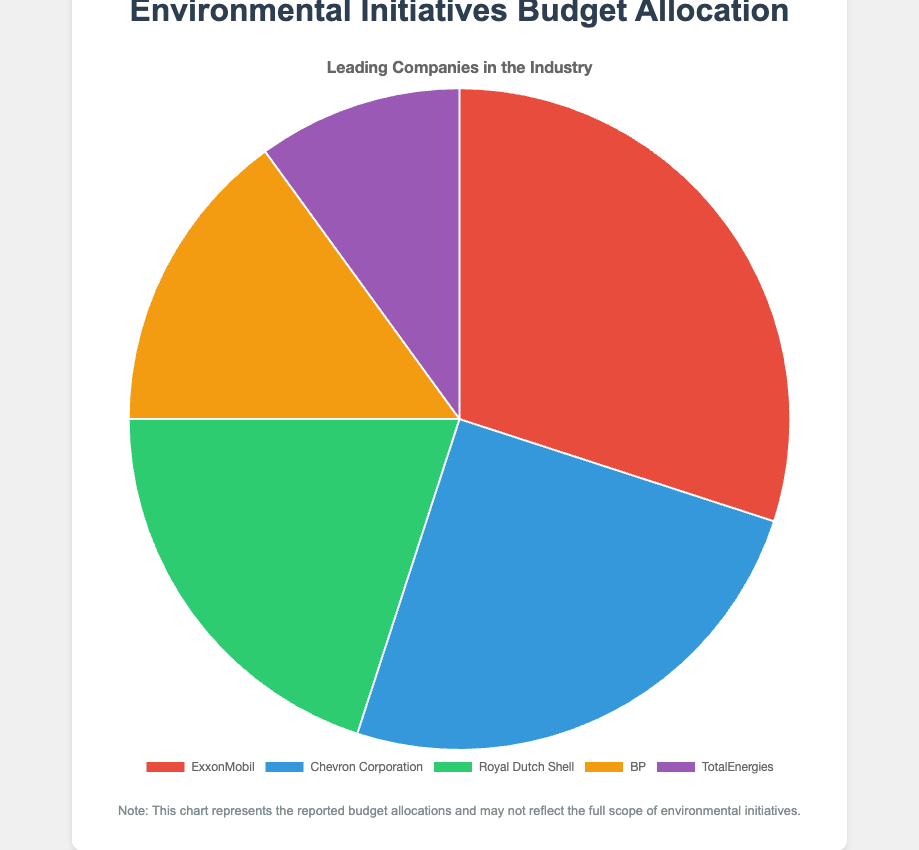What is the total budget allocated for environmental initiatives by all companies combined? The total budget is calculated by adding the individual budget allocations of each company. So, 300,000,000 (ExxonMobil) + 250,000,000 (Chevron Corporation) + 200,000,000 (Royal Dutch Shell) + 150,000,000 (BP) + 100,000,000 (TotalEnergies) = 1,000,000,000
Answer: 1,000,000,000 Which company has allocated the largest budget for environmental initiatives? The company with the largest budget is identified by comparing the budget allocations of all companies. ExxonMobil has the largest allocation of 300,000,000
Answer: ExxonMobil How much more has ExxonMobil allocated compared to TotalEnergies? The difference is found by subtracting TotalEnergies's budget from ExxonMobil's budget. So, 300,000,000 (ExxonMobil) - 100,000,000 (TotalEnergies) = 200,000,000
Answer: 200,000,000 What is the average budget allocation for the environmental initiatives? The average is calculated by dividing the total budget by the number of companies. So, 1,000,000,000 / 5 = 200,000,000
Answer: 200,000,000 What percentage of the total budget is allocated by Chevron Corporation? The percentage is calculated by dividing Chevron Corporation's budget by the total budget and then multiplying by 100. So, (250,000,000 / 1,000,000,000) * 100 = 25%
Answer: 25% Which company has allocated the smallest budget and what color is it represented by in the chart? The company with the smallest budget is identified first, and then its representative color is noted from the chart. TotalEnergies has the smallest budget of 100,000,000 and is represented by purple
Answer: TotalEnergies, purple How does the budget allocation of BP compare to Royal Dutch Shell in terms of percentage? The comparison in percentage is done by first finding the individual percentages of both companies. For BP: (150,000,000 / 1,000,000,000) * 100 = 15%. For Royal Dutch Shell: (200,000,000 / 1,000,000,000) * 100 = 20%. Then comparison shows BP's allocation is 5% less than Royal Dutch Shell
Answer: BP's allocation is 5% less than Royal Dutch Shell Rank the companies from highest to lowest budget allocation. The ranking is determined by sorting the companies based on their budget allocations. The order is: ExxonMobil (300,000,000), Chevron Corporation (250,000,000), Royal Dutch Shell (200,000,000), BP (150,000,000), TotalEnergies (100,000,000)
Answer: ExxonMobil, Chevron Corporation, Royal Dutch Shell, BP, TotalEnergies What's the combined budget allocation of the top two companies with the highest budgets? The combined budget is the sum of the budgets of the top two companies, ExxonMobil and Chevron Corporation. So, 300,000,000 + 250,000,000 = 550,000,000
Answer: 550,000,000 What is the difference between the total allocation of the top three companies compared to the bottom two companies? The top three companies are ExxonMobil, Chevron Corporation, and Royal Dutch Shell. Their combined allocation is 300,000,000 + 250,000,000 + 200,000,000 = 750,000,000. The bottom two companies are BP and TotalEnergies. Their combined allocation is 150,000,000 + 100,000,000 = 250,000,000. The difference is 750,000,000 - 250,000,000 = 500,000,000
Answer: 500,000,000 